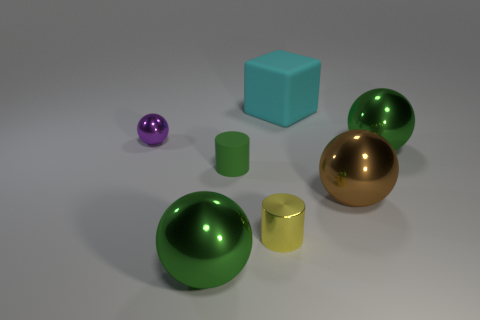Subtract all large brown balls. How many balls are left? 3 Subtract all purple balls. How many balls are left? 3 Add 2 big spheres. How many objects exist? 9 Subtract all cyan balls. Subtract all cyan cubes. How many balls are left? 4 Subtract all balls. How many objects are left? 3 Add 3 green matte cylinders. How many green matte cylinders are left? 4 Add 5 purple metallic cylinders. How many purple metallic cylinders exist? 5 Subtract 1 yellow cylinders. How many objects are left? 6 Subtract all big cyan shiny objects. Subtract all big cyan cubes. How many objects are left? 6 